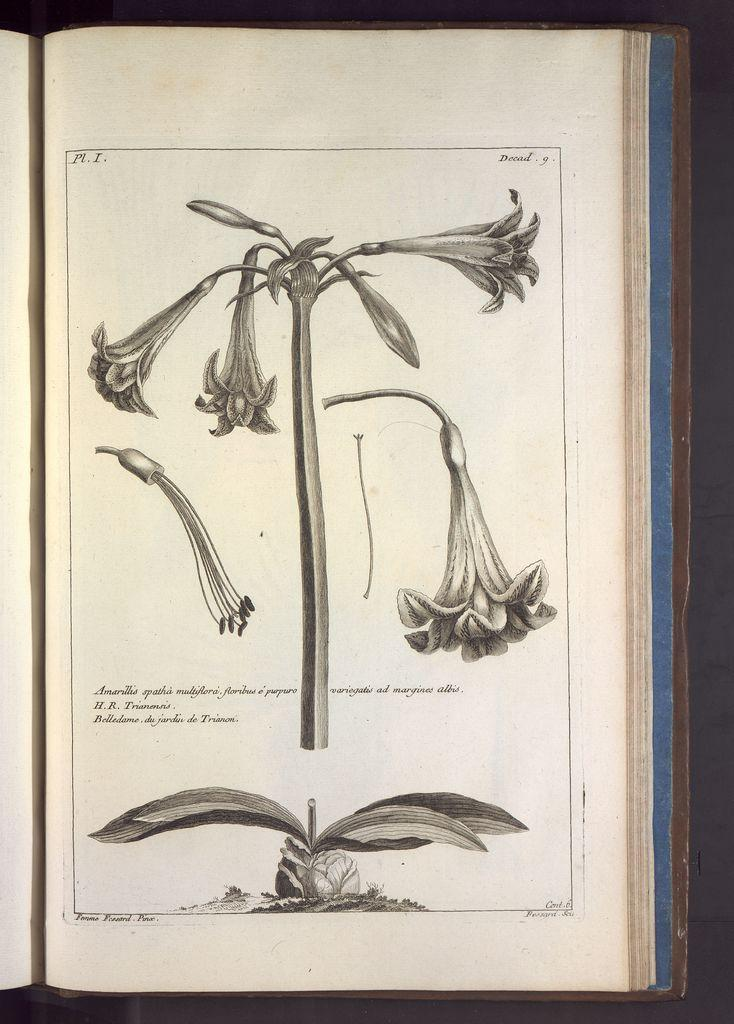What is depicted on the page in the image? There are flowers on a page in the image. How many hens are sitting on the clam in the image? There are no hens or clams present in the image; it features flowers on a page. 